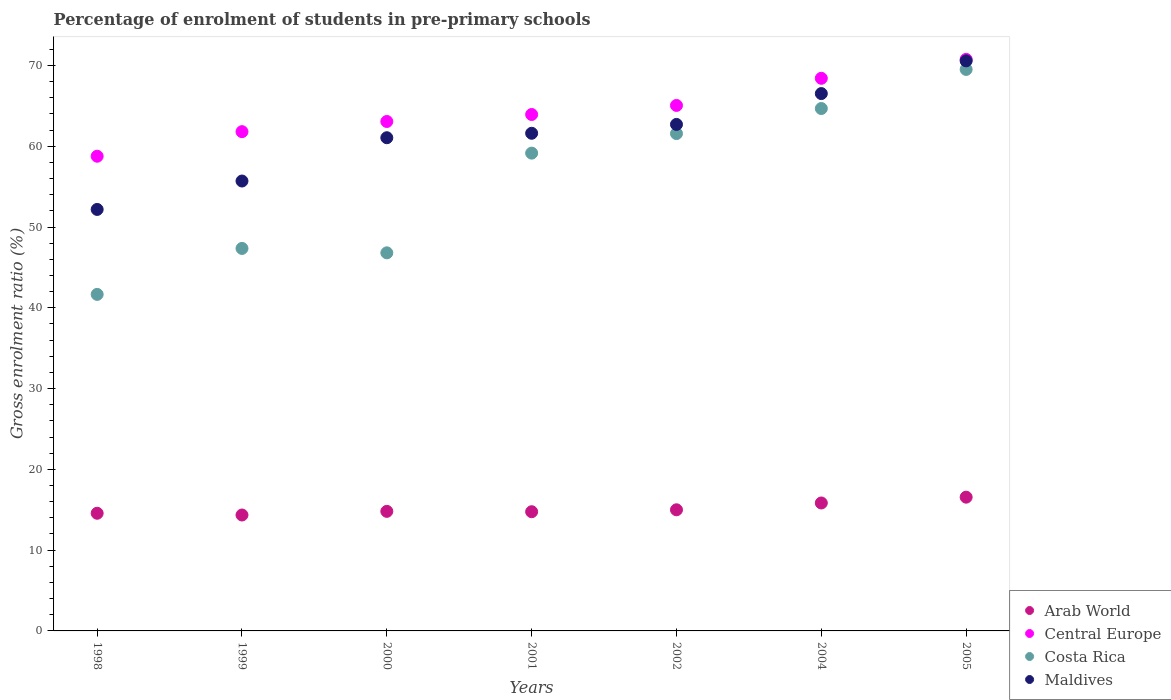Is the number of dotlines equal to the number of legend labels?
Your answer should be compact. Yes. What is the percentage of students enrolled in pre-primary schools in Costa Rica in 1999?
Give a very brief answer. 47.35. Across all years, what is the maximum percentage of students enrolled in pre-primary schools in Arab World?
Offer a terse response. 16.56. Across all years, what is the minimum percentage of students enrolled in pre-primary schools in Maldives?
Offer a very short reply. 52.17. In which year was the percentage of students enrolled in pre-primary schools in Costa Rica maximum?
Ensure brevity in your answer.  2005. In which year was the percentage of students enrolled in pre-primary schools in Maldives minimum?
Your answer should be compact. 1998. What is the total percentage of students enrolled in pre-primary schools in Costa Rica in the graph?
Give a very brief answer. 390.69. What is the difference between the percentage of students enrolled in pre-primary schools in Maldives in 2000 and that in 2001?
Provide a short and direct response. -0.55. What is the difference between the percentage of students enrolled in pre-primary schools in Maldives in 2002 and the percentage of students enrolled in pre-primary schools in Arab World in 2001?
Your answer should be compact. 47.94. What is the average percentage of students enrolled in pre-primary schools in Central Europe per year?
Ensure brevity in your answer.  64.54. In the year 2004, what is the difference between the percentage of students enrolled in pre-primary schools in Costa Rica and percentage of students enrolled in pre-primary schools in Maldives?
Keep it short and to the point. -1.85. What is the ratio of the percentage of students enrolled in pre-primary schools in Central Europe in 2004 to that in 2005?
Offer a terse response. 0.97. Is the percentage of students enrolled in pre-primary schools in Central Europe in 1998 less than that in 2000?
Give a very brief answer. Yes. Is the difference between the percentage of students enrolled in pre-primary schools in Costa Rica in 1998 and 2002 greater than the difference between the percentage of students enrolled in pre-primary schools in Maldives in 1998 and 2002?
Provide a short and direct response. No. What is the difference between the highest and the second highest percentage of students enrolled in pre-primary schools in Maldives?
Offer a terse response. 4.05. What is the difference between the highest and the lowest percentage of students enrolled in pre-primary schools in Costa Rica?
Give a very brief answer. 27.85. Does the percentage of students enrolled in pre-primary schools in Arab World monotonically increase over the years?
Your answer should be compact. No. Is the percentage of students enrolled in pre-primary schools in Maldives strictly greater than the percentage of students enrolled in pre-primary schools in Costa Rica over the years?
Keep it short and to the point. Yes. Is the percentage of students enrolled in pre-primary schools in Arab World strictly less than the percentage of students enrolled in pre-primary schools in Central Europe over the years?
Your answer should be very brief. Yes. How many years are there in the graph?
Your answer should be very brief. 7. What is the difference between two consecutive major ticks on the Y-axis?
Give a very brief answer. 10. Are the values on the major ticks of Y-axis written in scientific E-notation?
Offer a very short reply. No. Does the graph contain any zero values?
Your response must be concise. No. What is the title of the graph?
Your answer should be compact. Percentage of enrolment of students in pre-primary schools. What is the label or title of the X-axis?
Give a very brief answer. Years. What is the Gross enrolment ratio (%) in Arab World in 1998?
Provide a succinct answer. 14.56. What is the Gross enrolment ratio (%) of Central Europe in 1998?
Offer a terse response. 58.76. What is the Gross enrolment ratio (%) of Costa Rica in 1998?
Give a very brief answer. 41.66. What is the Gross enrolment ratio (%) in Maldives in 1998?
Offer a terse response. 52.17. What is the Gross enrolment ratio (%) of Arab World in 1999?
Your response must be concise. 14.35. What is the Gross enrolment ratio (%) in Central Europe in 1999?
Your answer should be compact. 61.8. What is the Gross enrolment ratio (%) in Costa Rica in 1999?
Provide a succinct answer. 47.35. What is the Gross enrolment ratio (%) of Maldives in 1999?
Offer a very short reply. 55.69. What is the Gross enrolment ratio (%) of Arab World in 2000?
Offer a very short reply. 14.8. What is the Gross enrolment ratio (%) of Central Europe in 2000?
Make the answer very short. 63.06. What is the Gross enrolment ratio (%) of Costa Rica in 2000?
Your answer should be compact. 46.8. What is the Gross enrolment ratio (%) in Maldives in 2000?
Keep it short and to the point. 61.05. What is the Gross enrolment ratio (%) of Arab World in 2001?
Your answer should be very brief. 14.76. What is the Gross enrolment ratio (%) in Central Europe in 2001?
Provide a short and direct response. 63.93. What is the Gross enrolment ratio (%) of Costa Rica in 2001?
Provide a short and direct response. 59.14. What is the Gross enrolment ratio (%) in Maldives in 2001?
Provide a short and direct response. 61.6. What is the Gross enrolment ratio (%) in Arab World in 2002?
Offer a terse response. 14.99. What is the Gross enrolment ratio (%) in Central Europe in 2002?
Make the answer very short. 65.05. What is the Gross enrolment ratio (%) of Costa Rica in 2002?
Give a very brief answer. 61.56. What is the Gross enrolment ratio (%) in Maldives in 2002?
Provide a succinct answer. 62.7. What is the Gross enrolment ratio (%) in Arab World in 2004?
Your answer should be compact. 15.84. What is the Gross enrolment ratio (%) of Central Europe in 2004?
Make the answer very short. 68.41. What is the Gross enrolment ratio (%) of Costa Rica in 2004?
Make the answer very short. 64.67. What is the Gross enrolment ratio (%) of Maldives in 2004?
Keep it short and to the point. 66.52. What is the Gross enrolment ratio (%) in Arab World in 2005?
Your answer should be very brief. 16.56. What is the Gross enrolment ratio (%) of Central Europe in 2005?
Your answer should be compact. 70.75. What is the Gross enrolment ratio (%) of Costa Rica in 2005?
Ensure brevity in your answer.  69.51. What is the Gross enrolment ratio (%) in Maldives in 2005?
Offer a very short reply. 70.57. Across all years, what is the maximum Gross enrolment ratio (%) of Arab World?
Provide a short and direct response. 16.56. Across all years, what is the maximum Gross enrolment ratio (%) of Central Europe?
Provide a short and direct response. 70.75. Across all years, what is the maximum Gross enrolment ratio (%) in Costa Rica?
Ensure brevity in your answer.  69.51. Across all years, what is the maximum Gross enrolment ratio (%) of Maldives?
Your answer should be very brief. 70.57. Across all years, what is the minimum Gross enrolment ratio (%) in Arab World?
Provide a succinct answer. 14.35. Across all years, what is the minimum Gross enrolment ratio (%) in Central Europe?
Keep it short and to the point. 58.76. Across all years, what is the minimum Gross enrolment ratio (%) of Costa Rica?
Provide a short and direct response. 41.66. Across all years, what is the minimum Gross enrolment ratio (%) in Maldives?
Provide a short and direct response. 52.17. What is the total Gross enrolment ratio (%) of Arab World in the graph?
Give a very brief answer. 105.86. What is the total Gross enrolment ratio (%) of Central Europe in the graph?
Your answer should be compact. 451.76. What is the total Gross enrolment ratio (%) in Costa Rica in the graph?
Provide a short and direct response. 390.69. What is the total Gross enrolment ratio (%) in Maldives in the graph?
Provide a short and direct response. 430.3. What is the difference between the Gross enrolment ratio (%) of Arab World in 1998 and that in 1999?
Your response must be concise. 0.22. What is the difference between the Gross enrolment ratio (%) of Central Europe in 1998 and that in 1999?
Provide a short and direct response. -3.04. What is the difference between the Gross enrolment ratio (%) of Costa Rica in 1998 and that in 1999?
Offer a very short reply. -5.69. What is the difference between the Gross enrolment ratio (%) of Maldives in 1998 and that in 1999?
Ensure brevity in your answer.  -3.52. What is the difference between the Gross enrolment ratio (%) in Arab World in 1998 and that in 2000?
Your answer should be compact. -0.24. What is the difference between the Gross enrolment ratio (%) in Central Europe in 1998 and that in 2000?
Give a very brief answer. -4.3. What is the difference between the Gross enrolment ratio (%) in Costa Rica in 1998 and that in 2000?
Keep it short and to the point. -5.14. What is the difference between the Gross enrolment ratio (%) in Maldives in 1998 and that in 2000?
Provide a succinct answer. -8.88. What is the difference between the Gross enrolment ratio (%) in Arab World in 1998 and that in 2001?
Offer a terse response. -0.19. What is the difference between the Gross enrolment ratio (%) in Central Europe in 1998 and that in 2001?
Your response must be concise. -5.17. What is the difference between the Gross enrolment ratio (%) in Costa Rica in 1998 and that in 2001?
Provide a succinct answer. -17.49. What is the difference between the Gross enrolment ratio (%) of Maldives in 1998 and that in 2001?
Offer a very short reply. -9.43. What is the difference between the Gross enrolment ratio (%) of Arab World in 1998 and that in 2002?
Your response must be concise. -0.43. What is the difference between the Gross enrolment ratio (%) of Central Europe in 1998 and that in 2002?
Provide a succinct answer. -6.29. What is the difference between the Gross enrolment ratio (%) in Costa Rica in 1998 and that in 2002?
Keep it short and to the point. -19.91. What is the difference between the Gross enrolment ratio (%) in Maldives in 1998 and that in 2002?
Ensure brevity in your answer.  -10.53. What is the difference between the Gross enrolment ratio (%) in Arab World in 1998 and that in 2004?
Provide a short and direct response. -1.27. What is the difference between the Gross enrolment ratio (%) in Central Europe in 1998 and that in 2004?
Make the answer very short. -9.65. What is the difference between the Gross enrolment ratio (%) of Costa Rica in 1998 and that in 2004?
Provide a succinct answer. -23.01. What is the difference between the Gross enrolment ratio (%) in Maldives in 1998 and that in 2004?
Your answer should be compact. -14.34. What is the difference between the Gross enrolment ratio (%) in Arab World in 1998 and that in 2005?
Keep it short and to the point. -1.99. What is the difference between the Gross enrolment ratio (%) in Central Europe in 1998 and that in 2005?
Your response must be concise. -11.99. What is the difference between the Gross enrolment ratio (%) of Costa Rica in 1998 and that in 2005?
Give a very brief answer. -27.85. What is the difference between the Gross enrolment ratio (%) of Maldives in 1998 and that in 2005?
Offer a very short reply. -18.39. What is the difference between the Gross enrolment ratio (%) of Arab World in 1999 and that in 2000?
Provide a succinct answer. -0.45. What is the difference between the Gross enrolment ratio (%) of Central Europe in 1999 and that in 2000?
Your answer should be compact. -1.26. What is the difference between the Gross enrolment ratio (%) in Costa Rica in 1999 and that in 2000?
Provide a short and direct response. 0.55. What is the difference between the Gross enrolment ratio (%) of Maldives in 1999 and that in 2000?
Make the answer very short. -5.36. What is the difference between the Gross enrolment ratio (%) in Arab World in 1999 and that in 2001?
Make the answer very short. -0.41. What is the difference between the Gross enrolment ratio (%) of Central Europe in 1999 and that in 2001?
Give a very brief answer. -2.12. What is the difference between the Gross enrolment ratio (%) of Costa Rica in 1999 and that in 2001?
Your answer should be compact. -11.8. What is the difference between the Gross enrolment ratio (%) in Maldives in 1999 and that in 2001?
Your answer should be very brief. -5.91. What is the difference between the Gross enrolment ratio (%) in Arab World in 1999 and that in 2002?
Your answer should be compact. -0.65. What is the difference between the Gross enrolment ratio (%) in Central Europe in 1999 and that in 2002?
Offer a very short reply. -3.24. What is the difference between the Gross enrolment ratio (%) of Costa Rica in 1999 and that in 2002?
Ensure brevity in your answer.  -14.22. What is the difference between the Gross enrolment ratio (%) in Maldives in 1999 and that in 2002?
Ensure brevity in your answer.  -7.01. What is the difference between the Gross enrolment ratio (%) in Arab World in 1999 and that in 2004?
Keep it short and to the point. -1.49. What is the difference between the Gross enrolment ratio (%) in Central Europe in 1999 and that in 2004?
Provide a succinct answer. -6.6. What is the difference between the Gross enrolment ratio (%) in Costa Rica in 1999 and that in 2004?
Provide a succinct answer. -17.32. What is the difference between the Gross enrolment ratio (%) of Maldives in 1999 and that in 2004?
Your answer should be compact. -10.82. What is the difference between the Gross enrolment ratio (%) of Arab World in 1999 and that in 2005?
Your answer should be compact. -2.21. What is the difference between the Gross enrolment ratio (%) in Central Europe in 1999 and that in 2005?
Keep it short and to the point. -8.95. What is the difference between the Gross enrolment ratio (%) of Costa Rica in 1999 and that in 2005?
Provide a short and direct response. -22.16. What is the difference between the Gross enrolment ratio (%) in Maldives in 1999 and that in 2005?
Give a very brief answer. -14.88. What is the difference between the Gross enrolment ratio (%) in Arab World in 2000 and that in 2001?
Provide a short and direct response. 0.05. What is the difference between the Gross enrolment ratio (%) in Central Europe in 2000 and that in 2001?
Your answer should be very brief. -0.86. What is the difference between the Gross enrolment ratio (%) of Costa Rica in 2000 and that in 2001?
Provide a short and direct response. -12.34. What is the difference between the Gross enrolment ratio (%) in Maldives in 2000 and that in 2001?
Ensure brevity in your answer.  -0.55. What is the difference between the Gross enrolment ratio (%) of Arab World in 2000 and that in 2002?
Offer a terse response. -0.19. What is the difference between the Gross enrolment ratio (%) in Central Europe in 2000 and that in 2002?
Keep it short and to the point. -1.99. What is the difference between the Gross enrolment ratio (%) in Costa Rica in 2000 and that in 2002?
Your answer should be compact. -14.76. What is the difference between the Gross enrolment ratio (%) of Maldives in 2000 and that in 2002?
Give a very brief answer. -1.65. What is the difference between the Gross enrolment ratio (%) in Arab World in 2000 and that in 2004?
Provide a succinct answer. -1.04. What is the difference between the Gross enrolment ratio (%) of Central Europe in 2000 and that in 2004?
Offer a very short reply. -5.35. What is the difference between the Gross enrolment ratio (%) in Costa Rica in 2000 and that in 2004?
Keep it short and to the point. -17.86. What is the difference between the Gross enrolment ratio (%) of Maldives in 2000 and that in 2004?
Offer a terse response. -5.46. What is the difference between the Gross enrolment ratio (%) of Arab World in 2000 and that in 2005?
Your response must be concise. -1.76. What is the difference between the Gross enrolment ratio (%) of Central Europe in 2000 and that in 2005?
Provide a short and direct response. -7.69. What is the difference between the Gross enrolment ratio (%) in Costa Rica in 2000 and that in 2005?
Your answer should be very brief. -22.7. What is the difference between the Gross enrolment ratio (%) in Maldives in 2000 and that in 2005?
Give a very brief answer. -9.52. What is the difference between the Gross enrolment ratio (%) in Arab World in 2001 and that in 2002?
Your answer should be compact. -0.24. What is the difference between the Gross enrolment ratio (%) of Central Europe in 2001 and that in 2002?
Provide a short and direct response. -1.12. What is the difference between the Gross enrolment ratio (%) in Costa Rica in 2001 and that in 2002?
Ensure brevity in your answer.  -2.42. What is the difference between the Gross enrolment ratio (%) in Maldives in 2001 and that in 2002?
Offer a very short reply. -1.1. What is the difference between the Gross enrolment ratio (%) of Arab World in 2001 and that in 2004?
Your response must be concise. -1.08. What is the difference between the Gross enrolment ratio (%) of Central Europe in 2001 and that in 2004?
Make the answer very short. -4.48. What is the difference between the Gross enrolment ratio (%) of Costa Rica in 2001 and that in 2004?
Your answer should be compact. -5.52. What is the difference between the Gross enrolment ratio (%) in Maldives in 2001 and that in 2004?
Give a very brief answer. -4.91. What is the difference between the Gross enrolment ratio (%) in Arab World in 2001 and that in 2005?
Your response must be concise. -1.8. What is the difference between the Gross enrolment ratio (%) of Central Europe in 2001 and that in 2005?
Provide a succinct answer. -6.83. What is the difference between the Gross enrolment ratio (%) in Costa Rica in 2001 and that in 2005?
Offer a terse response. -10.36. What is the difference between the Gross enrolment ratio (%) of Maldives in 2001 and that in 2005?
Provide a succinct answer. -8.96. What is the difference between the Gross enrolment ratio (%) in Arab World in 2002 and that in 2004?
Offer a terse response. -0.84. What is the difference between the Gross enrolment ratio (%) in Central Europe in 2002 and that in 2004?
Offer a very short reply. -3.36. What is the difference between the Gross enrolment ratio (%) in Costa Rica in 2002 and that in 2004?
Make the answer very short. -3.1. What is the difference between the Gross enrolment ratio (%) of Maldives in 2002 and that in 2004?
Make the answer very short. -3.82. What is the difference between the Gross enrolment ratio (%) in Arab World in 2002 and that in 2005?
Your answer should be very brief. -1.56. What is the difference between the Gross enrolment ratio (%) in Central Europe in 2002 and that in 2005?
Provide a succinct answer. -5.7. What is the difference between the Gross enrolment ratio (%) of Costa Rica in 2002 and that in 2005?
Provide a succinct answer. -7.94. What is the difference between the Gross enrolment ratio (%) of Maldives in 2002 and that in 2005?
Make the answer very short. -7.87. What is the difference between the Gross enrolment ratio (%) in Arab World in 2004 and that in 2005?
Your answer should be very brief. -0.72. What is the difference between the Gross enrolment ratio (%) in Central Europe in 2004 and that in 2005?
Make the answer very short. -2.35. What is the difference between the Gross enrolment ratio (%) in Costa Rica in 2004 and that in 2005?
Your response must be concise. -4.84. What is the difference between the Gross enrolment ratio (%) of Maldives in 2004 and that in 2005?
Your answer should be very brief. -4.05. What is the difference between the Gross enrolment ratio (%) in Arab World in 1998 and the Gross enrolment ratio (%) in Central Europe in 1999?
Offer a very short reply. -47.24. What is the difference between the Gross enrolment ratio (%) of Arab World in 1998 and the Gross enrolment ratio (%) of Costa Rica in 1999?
Provide a succinct answer. -32.78. What is the difference between the Gross enrolment ratio (%) in Arab World in 1998 and the Gross enrolment ratio (%) in Maldives in 1999?
Your answer should be very brief. -41.13. What is the difference between the Gross enrolment ratio (%) of Central Europe in 1998 and the Gross enrolment ratio (%) of Costa Rica in 1999?
Keep it short and to the point. 11.41. What is the difference between the Gross enrolment ratio (%) in Central Europe in 1998 and the Gross enrolment ratio (%) in Maldives in 1999?
Provide a short and direct response. 3.07. What is the difference between the Gross enrolment ratio (%) of Costa Rica in 1998 and the Gross enrolment ratio (%) of Maldives in 1999?
Your answer should be compact. -14.03. What is the difference between the Gross enrolment ratio (%) of Arab World in 1998 and the Gross enrolment ratio (%) of Central Europe in 2000?
Give a very brief answer. -48.5. What is the difference between the Gross enrolment ratio (%) in Arab World in 1998 and the Gross enrolment ratio (%) in Costa Rica in 2000?
Provide a succinct answer. -32.24. What is the difference between the Gross enrolment ratio (%) in Arab World in 1998 and the Gross enrolment ratio (%) in Maldives in 2000?
Your response must be concise. -46.49. What is the difference between the Gross enrolment ratio (%) in Central Europe in 1998 and the Gross enrolment ratio (%) in Costa Rica in 2000?
Your answer should be very brief. 11.96. What is the difference between the Gross enrolment ratio (%) of Central Europe in 1998 and the Gross enrolment ratio (%) of Maldives in 2000?
Provide a short and direct response. -2.29. What is the difference between the Gross enrolment ratio (%) of Costa Rica in 1998 and the Gross enrolment ratio (%) of Maldives in 2000?
Provide a short and direct response. -19.39. What is the difference between the Gross enrolment ratio (%) of Arab World in 1998 and the Gross enrolment ratio (%) of Central Europe in 2001?
Your answer should be very brief. -49.36. What is the difference between the Gross enrolment ratio (%) of Arab World in 1998 and the Gross enrolment ratio (%) of Costa Rica in 2001?
Give a very brief answer. -44.58. What is the difference between the Gross enrolment ratio (%) in Arab World in 1998 and the Gross enrolment ratio (%) in Maldives in 2001?
Provide a succinct answer. -47.04. What is the difference between the Gross enrolment ratio (%) of Central Europe in 1998 and the Gross enrolment ratio (%) of Costa Rica in 2001?
Your answer should be very brief. -0.38. What is the difference between the Gross enrolment ratio (%) of Central Europe in 1998 and the Gross enrolment ratio (%) of Maldives in 2001?
Offer a very short reply. -2.84. What is the difference between the Gross enrolment ratio (%) in Costa Rica in 1998 and the Gross enrolment ratio (%) in Maldives in 2001?
Your response must be concise. -19.94. What is the difference between the Gross enrolment ratio (%) of Arab World in 1998 and the Gross enrolment ratio (%) of Central Europe in 2002?
Offer a very short reply. -50.48. What is the difference between the Gross enrolment ratio (%) of Arab World in 1998 and the Gross enrolment ratio (%) of Costa Rica in 2002?
Your response must be concise. -47. What is the difference between the Gross enrolment ratio (%) in Arab World in 1998 and the Gross enrolment ratio (%) in Maldives in 2002?
Your answer should be very brief. -48.13. What is the difference between the Gross enrolment ratio (%) of Central Europe in 1998 and the Gross enrolment ratio (%) of Costa Rica in 2002?
Your answer should be very brief. -2.8. What is the difference between the Gross enrolment ratio (%) in Central Europe in 1998 and the Gross enrolment ratio (%) in Maldives in 2002?
Your response must be concise. -3.94. What is the difference between the Gross enrolment ratio (%) of Costa Rica in 1998 and the Gross enrolment ratio (%) of Maldives in 2002?
Keep it short and to the point. -21.04. What is the difference between the Gross enrolment ratio (%) of Arab World in 1998 and the Gross enrolment ratio (%) of Central Europe in 2004?
Your answer should be very brief. -53.84. What is the difference between the Gross enrolment ratio (%) of Arab World in 1998 and the Gross enrolment ratio (%) of Costa Rica in 2004?
Ensure brevity in your answer.  -50.1. What is the difference between the Gross enrolment ratio (%) in Arab World in 1998 and the Gross enrolment ratio (%) in Maldives in 2004?
Provide a short and direct response. -51.95. What is the difference between the Gross enrolment ratio (%) in Central Europe in 1998 and the Gross enrolment ratio (%) in Costa Rica in 2004?
Give a very brief answer. -5.91. What is the difference between the Gross enrolment ratio (%) in Central Europe in 1998 and the Gross enrolment ratio (%) in Maldives in 2004?
Your response must be concise. -7.76. What is the difference between the Gross enrolment ratio (%) of Costa Rica in 1998 and the Gross enrolment ratio (%) of Maldives in 2004?
Offer a terse response. -24.86. What is the difference between the Gross enrolment ratio (%) in Arab World in 1998 and the Gross enrolment ratio (%) in Central Europe in 2005?
Ensure brevity in your answer.  -56.19. What is the difference between the Gross enrolment ratio (%) in Arab World in 1998 and the Gross enrolment ratio (%) in Costa Rica in 2005?
Provide a succinct answer. -54.94. What is the difference between the Gross enrolment ratio (%) in Arab World in 1998 and the Gross enrolment ratio (%) in Maldives in 2005?
Make the answer very short. -56. What is the difference between the Gross enrolment ratio (%) of Central Europe in 1998 and the Gross enrolment ratio (%) of Costa Rica in 2005?
Provide a succinct answer. -10.75. What is the difference between the Gross enrolment ratio (%) of Central Europe in 1998 and the Gross enrolment ratio (%) of Maldives in 2005?
Your answer should be very brief. -11.81. What is the difference between the Gross enrolment ratio (%) in Costa Rica in 1998 and the Gross enrolment ratio (%) in Maldives in 2005?
Your answer should be compact. -28.91. What is the difference between the Gross enrolment ratio (%) of Arab World in 1999 and the Gross enrolment ratio (%) of Central Europe in 2000?
Provide a succinct answer. -48.71. What is the difference between the Gross enrolment ratio (%) in Arab World in 1999 and the Gross enrolment ratio (%) in Costa Rica in 2000?
Provide a succinct answer. -32.45. What is the difference between the Gross enrolment ratio (%) of Arab World in 1999 and the Gross enrolment ratio (%) of Maldives in 2000?
Offer a terse response. -46.7. What is the difference between the Gross enrolment ratio (%) of Central Europe in 1999 and the Gross enrolment ratio (%) of Costa Rica in 2000?
Offer a terse response. 15. What is the difference between the Gross enrolment ratio (%) in Central Europe in 1999 and the Gross enrolment ratio (%) in Maldives in 2000?
Offer a very short reply. 0.75. What is the difference between the Gross enrolment ratio (%) of Costa Rica in 1999 and the Gross enrolment ratio (%) of Maldives in 2000?
Ensure brevity in your answer.  -13.7. What is the difference between the Gross enrolment ratio (%) of Arab World in 1999 and the Gross enrolment ratio (%) of Central Europe in 2001?
Your response must be concise. -49.58. What is the difference between the Gross enrolment ratio (%) of Arab World in 1999 and the Gross enrolment ratio (%) of Costa Rica in 2001?
Give a very brief answer. -44.8. What is the difference between the Gross enrolment ratio (%) in Arab World in 1999 and the Gross enrolment ratio (%) in Maldives in 2001?
Your response must be concise. -47.25. What is the difference between the Gross enrolment ratio (%) of Central Europe in 1999 and the Gross enrolment ratio (%) of Costa Rica in 2001?
Provide a succinct answer. 2.66. What is the difference between the Gross enrolment ratio (%) of Central Europe in 1999 and the Gross enrolment ratio (%) of Maldives in 2001?
Your answer should be very brief. 0.2. What is the difference between the Gross enrolment ratio (%) in Costa Rica in 1999 and the Gross enrolment ratio (%) in Maldives in 2001?
Offer a terse response. -14.25. What is the difference between the Gross enrolment ratio (%) in Arab World in 1999 and the Gross enrolment ratio (%) in Central Europe in 2002?
Your response must be concise. -50.7. What is the difference between the Gross enrolment ratio (%) of Arab World in 1999 and the Gross enrolment ratio (%) of Costa Rica in 2002?
Provide a succinct answer. -47.21. What is the difference between the Gross enrolment ratio (%) of Arab World in 1999 and the Gross enrolment ratio (%) of Maldives in 2002?
Your response must be concise. -48.35. What is the difference between the Gross enrolment ratio (%) in Central Europe in 1999 and the Gross enrolment ratio (%) in Costa Rica in 2002?
Offer a terse response. 0.24. What is the difference between the Gross enrolment ratio (%) in Central Europe in 1999 and the Gross enrolment ratio (%) in Maldives in 2002?
Make the answer very short. -0.9. What is the difference between the Gross enrolment ratio (%) in Costa Rica in 1999 and the Gross enrolment ratio (%) in Maldives in 2002?
Your answer should be compact. -15.35. What is the difference between the Gross enrolment ratio (%) in Arab World in 1999 and the Gross enrolment ratio (%) in Central Europe in 2004?
Your answer should be very brief. -54.06. What is the difference between the Gross enrolment ratio (%) of Arab World in 1999 and the Gross enrolment ratio (%) of Costa Rica in 2004?
Keep it short and to the point. -50.32. What is the difference between the Gross enrolment ratio (%) in Arab World in 1999 and the Gross enrolment ratio (%) in Maldives in 2004?
Make the answer very short. -52.17. What is the difference between the Gross enrolment ratio (%) of Central Europe in 1999 and the Gross enrolment ratio (%) of Costa Rica in 2004?
Your response must be concise. -2.86. What is the difference between the Gross enrolment ratio (%) of Central Europe in 1999 and the Gross enrolment ratio (%) of Maldives in 2004?
Your response must be concise. -4.71. What is the difference between the Gross enrolment ratio (%) of Costa Rica in 1999 and the Gross enrolment ratio (%) of Maldives in 2004?
Ensure brevity in your answer.  -19.17. What is the difference between the Gross enrolment ratio (%) in Arab World in 1999 and the Gross enrolment ratio (%) in Central Europe in 2005?
Give a very brief answer. -56.4. What is the difference between the Gross enrolment ratio (%) of Arab World in 1999 and the Gross enrolment ratio (%) of Costa Rica in 2005?
Your response must be concise. -55.16. What is the difference between the Gross enrolment ratio (%) of Arab World in 1999 and the Gross enrolment ratio (%) of Maldives in 2005?
Offer a terse response. -56.22. What is the difference between the Gross enrolment ratio (%) in Central Europe in 1999 and the Gross enrolment ratio (%) in Costa Rica in 2005?
Give a very brief answer. -7.7. What is the difference between the Gross enrolment ratio (%) in Central Europe in 1999 and the Gross enrolment ratio (%) in Maldives in 2005?
Ensure brevity in your answer.  -8.76. What is the difference between the Gross enrolment ratio (%) in Costa Rica in 1999 and the Gross enrolment ratio (%) in Maldives in 2005?
Offer a terse response. -23.22. What is the difference between the Gross enrolment ratio (%) of Arab World in 2000 and the Gross enrolment ratio (%) of Central Europe in 2001?
Keep it short and to the point. -49.13. What is the difference between the Gross enrolment ratio (%) in Arab World in 2000 and the Gross enrolment ratio (%) in Costa Rica in 2001?
Your response must be concise. -44.34. What is the difference between the Gross enrolment ratio (%) in Arab World in 2000 and the Gross enrolment ratio (%) in Maldives in 2001?
Provide a succinct answer. -46.8. What is the difference between the Gross enrolment ratio (%) in Central Europe in 2000 and the Gross enrolment ratio (%) in Costa Rica in 2001?
Your response must be concise. 3.92. What is the difference between the Gross enrolment ratio (%) in Central Europe in 2000 and the Gross enrolment ratio (%) in Maldives in 2001?
Your response must be concise. 1.46. What is the difference between the Gross enrolment ratio (%) in Costa Rica in 2000 and the Gross enrolment ratio (%) in Maldives in 2001?
Your answer should be very brief. -14.8. What is the difference between the Gross enrolment ratio (%) in Arab World in 2000 and the Gross enrolment ratio (%) in Central Europe in 2002?
Keep it short and to the point. -50.25. What is the difference between the Gross enrolment ratio (%) of Arab World in 2000 and the Gross enrolment ratio (%) of Costa Rica in 2002?
Offer a very short reply. -46.76. What is the difference between the Gross enrolment ratio (%) of Arab World in 2000 and the Gross enrolment ratio (%) of Maldives in 2002?
Keep it short and to the point. -47.9. What is the difference between the Gross enrolment ratio (%) of Central Europe in 2000 and the Gross enrolment ratio (%) of Costa Rica in 2002?
Provide a short and direct response. 1.5. What is the difference between the Gross enrolment ratio (%) of Central Europe in 2000 and the Gross enrolment ratio (%) of Maldives in 2002?
Your answer should be compact. 0.36. What is the difference between the Gross enrolment ratio (%) of Costa Rica in 2000 and the Gross enrolment ratio (%) of Maldives in 2002?
Keep it short and to the point. -15.9. What is the difference between the Gross enrolment ratio (%) of Arab World in 2000 and the Gross enrolment ratio (%) of Central Europe in 2004?
Ensure brevity in your answer.  -53.61. What is the difference between the Gross enrolment ratio (%) of Arab World in 2000 and the Gross enrolment ratio (%) of Costa Rica in 2004?
Your answer should be compact. -49.87. What is the difference between the Gross enrolment ratio (%) in Arab World in 2000 and the Gross enrolment ratio (%) in Maldives in 2004?
Keep it short and to the point. -51.72. What is the difference between the Gross enrolment ratio (%) in Central Europe in 2000 and the Gross enrolment ratio (%) in Costa Rica in 2004?
Give a very brief answer. -1.6. What is the difference between the Gross enrolment ratio (%) of Central Europe in 2000 and the Gross enrolment ratio (%) of Maldives in 2004?
Offer a terse response. -3.45. What is the difference between the Gross enrolment ratio (%) of Costa Rica in 2000 and the Gross enrolment ratio (%) of Maldives in 2004?
Make the answer very short. -19.71. What is the difference between the Gross enrolment ratio (%) in Arab World in 2000 and the Gross enrolment ratio (%) in Central Europe in 2005?
Offer a very short reply. -55.95. What is the difference between the Gross enrolment ratio (%) of Arab World in 2000 and the Gross enrolment ratio (%) of Costa Rica in 2005?
Your answer should be very brief. -54.71. What is the difference between the Gross enrolment ratio (%) in Arab World in 2000 and the Gross enrolment ratio (%) in Maldives in 2005?
Offer a very short reply. -55.77. What is the difference between the Gross enrolment ratio (%) in Central Europe in 2000 and the Gross enrolment ratio (%) in Costa Rica in 2005?
Offer a terse response. -6.44. What is the difference between the Gross enrolment ratio (%) in Central Europe in 2000 and the Gross enrolment ratio (%) in Maldives in 2005?
Ensure brevity in your answer.  -7.51. What is the difference between the Gross enrolment ratio (%) of Costa Rica in 2000 and the Gross enrolment ratio (%) of Maldives in 2005?
Make the answer very short. -23.76. What is the difference between the Gross enrolment ratio (%) of Arab World in 2001 and the Gross enrolment ratio (%) of Central Europe in 2002?
Your answer should be compact. -50.29. What is the difference between the Gross enrolment ratio (%) in Arab World in 2001 and the Gross enrolment ratio (%) in Costa Rica in 2002?
Your response must be concise. -46.81. What is the difference between the Gross enrolment ratio (%) in Arab World in 2001 and the Gross enrolment ratio (%) in Maldives in 2002?
Your response must be concise. -47.94. What is the difference between the Gross enrolment ratio (%) of Central Europe in 2001 and the Gross enrolment ratio (%) of Costa Rica in 2002?
Give a very brief answer. 2.36. What is the difference between the Gross enrolment ratio (%) of Central Europe in 2001 and the Gross enrolment ratio (%) of Maldives in 2002?
Offer a terse response. 1.23. What is the difference between the Gross enrolment ratio (%) in Costa Rica in 2001 and the Gross enrolment ratio (%) in Maldives in 2002?
Keep it short and to the point. -3.56. What is the difference between the Gross enrolment ratio (%) of Arab World in 2001 and the Gross enrolment ratio (%) of Central Europe in 2004?
Offer a very short reply. -53.65. What is the difference between the Gross enrolment ratio (%) of Arab World in 2001 and the Gross enrolment ratio (%) of Costa Rica in 2004?
Provide a short and direct response. -49.91. What is the difference between the Gross enrolment ratio (%) in Arab World in 2001 and the Gross enrolment ratio (%) in Maldives in 2004?
Provide a succinct answer. -51.76. What is the difference between the Gross enrolment ratio (%) of Central Europe in 2001 and the Gross enrolment ratio (%) of Costa Rica in 2004?
Your answer should be very brief. -0.74. What is the difference between the Gross enrolment ratio (%) in Central Europe in 2001 and the Gross enrolment ratio (%) in Maldives in 2004?
Make the answer very short. -2.59. What is the difference between the Gross enrolment ratio (%) of Costa Rica in 2001 and the Gross enrolment ratio (%) of Maldives in 2004?
Offer a very short reply. -7.37. What is the difference between the Gross enrolment ratio (%) of Arab World in 2001 and the Gross enrolment ratio (%) of Central Europe in 2005?
Give a very brief answer. -56. What is the difference between the Gross enrolment ratio (%) of Arab World in 2001 and the Gross enrolment ratio (%) of Costa Rica in 2005?
Your answer should be compact. -54.75. What is the difference between the Gross enrolment ratio (%) of Arab World in 2001 and the Gross enrolment ratio (%) of Maldives in 2005?
Make the answer very short. -55.81. What is the difference between the Gross enrolment ratio (%) of Central Europe in 2001 and the Gross enrolment ratio (%) of Costa Rica in 2005?
Give a very brief answer. -5.58. What is the difference between the Gross enrolment ratio (%) of Central Europe in 2001 and the Gross enrolment ratio (%) of Maldives in 2005?
Provide a short and direct response. -6.64. What is the difference between the Gross enrolment ratio (%) of Costa Rica in 2001 and the Gross enrolment ratio (%) of Maldives in 2005?
Offer a very short reply. -11.42. What is the difference between the Gross enrolment ratio (%) in Arab World in 2002 and the Gross enrolment ratio (%) in Central Europe in 2004?
Your response must be concise. -53.41. What is the difference between the Gross enrolment ratio (%) of Arab World in 2002 and the Gross enrolment ratio (%) of Costa Rica in 2004?
Ensure brevity in your answer.  -49.67. What is the difference between the Gross enrolment ratio (%) of Arab World in 2002 and the Gross enrolment ratio (%) of Maldives in 2004?
Give a very brief answer. -51.52. What is the difference between the Gross enrolment ratio (%) in Central Europe in 2002 and the Gross enrolment ratio (%) in Costa Rica in 2004?
Ensure brevity in your answer.  0.38. What is the difference between the Gross enrolment ratio (%) in Central Europe in 2002 and the Gross enrolment ratio (%) in Maldives in 2004?
Your answer should be very brief. -1.47. What is the difference between the Gross enrolment ratio (%) in Costa Rica in 2002 and the Gross enrolment ratio (%) in Maldives in 2004?
Ensure brevity in your answer.  -4.95. What is the difference between the Gross enrolment ratio (%) of Arab World in 2002 and the Gross enrolment ratio (%) of Central Europe in 2005?
Provide a succinct answer. -55.76. What is the difference between the Gross enrolment ratio (%) of Arab World in 2002 and the Gross enrolment ratio (%) of Costa Rica in 2005?
Give a very brief answer. -54.51. What is the difference between the Gross enrolment ratio (%) of Arab World in 2002 and the Gross enrolment ratio (%) of Maldives in 2005?
Your answer should be compact. -55.57. What is the difference between the Gross enrolment ratio (%) in Central Europe in 2002 and the Gross enrolment ratio (%) in Costa Rica in 2005?
Provide a short and direct response. -4.46. What is the difference between the Gross enrolment ratio (%) in Central Europe in 2002 and the Gross enrolment ratio (%) in Maldives in 2005?
Offer a very short reply. -5.52. What is the difference between the Gross enrolment ratio (%) in Costa Rica in 2002 and the Gross enrolment ratio (%) in Maldives in 2005?
Offer a terse response. -9. What is the difference between the Gross enrolment ratio (%) of Arab World in 2004 and the Gross enrolment ratio (%) of Central Europe in 2005?
Your answer should be very brief. -54.91. What is the difference between the Gross enrolment ratio (%) in Arab World in 2004 and the Gross enrolment ratio (%) in Costa Rica in 2005?
Your response must be concise. -53.67. What is the difference between the Gross enrolment ratio (%) in Arab World in 2004 and the Gross enrolment ratio (%) in Maldives in 2005?
Ensure brevity in your answer.  -54.73. What is the difference between the Gross enrolment ratio (%) of Central Europe in 2004 and the Gross enrolment ratio (%) of Costa Rica in 2005?
Keep it short and to the point. -1.1. What is the difference between the Gross enrolment ratio (%) in Central Europe in 2004 and the Gross enrolment ratio (%) in Maldives in 2005?
Your answer should be compact. -2.16. What is the difference between the Gross enrolment ratio (%) in Costa Rica in 2004 and the Gross enrolment ratio (%) in Maldives in 2005?
Make the answer very short. -5.9. What is the average Gross enrolment ratio (%) in Arab World per year?
Make the answer very short. 15.12. What is the average Gross enrolment ratio (%) of Central Europe per year?
Provide a short and direct response. 64.54. What is the average Gross enrolment ratio (%) of Costa Rica per year?
Provide a succinct answer. 55.81. What is the average Gross enrolment ratio (%) of Maldives per year?
Provide a short and direct response. 61.47. In the year 1998, what is the difference between the Gross enrolment ratio (%) in Arab World and Gross enrolment ratio (%) in Central Europe?
Give a very brief answer. -44.2. In the year 1998, what is the difference between the Gross enrolment ratio (%) in Arab World and Gross enrolment ratio (%) in Costa Rica?
Your answer should be compact. -27.09. In the year 1998, what is the difference between the Gross enrolment ratio (%) of Arab World and Gross enrolment ratio (%) of Maldives?
Your answer should be compact. -37.61. In the year 1998, what is the difference between the Gross enrolment ratio (%) in Central Europe and Gross enrolment ratio (%) in Costa Rica?
Offer a terse response. 17.1. In the year 1998, what is the difference between the Gross enrolment ratio (%) in Central Europe and Gross enrolment ratio (%) in Maldives?
Your answer should be very brief. 6.59. In the year 1998, what is the difference between the Gross enrolment ratio (%) in Costa Rica and Gross enrolment ratio (%) in Maldives?
Offer a very short reply. -10.52. In the year 1999, what is the difference between the Gross enrolment ratio (%) of Arab World and Gross enrolment ratio (%) of Central Europe?
Offer a very short reply. -47.45. In the year 1999, what is the difference between the Gross enrolment ratio (%) in Arab World and Gross enrolment ratio (%) in Costa Rica?
Your answer should be very brief. -33. In the year 1999, what is the difference between the Gross enrolment ratio (%) of Arab World and Gross enrolment ratio (%) of Maldives?
Provide a succinct answer. -41.34. In the year 1999, what is the difference between the Gross enrolment ratio (%) in Central Europe and Gross enrolment ratio (%) in Costa Rica?
Provide a short and direct response. 14.45. In the year 1999, what is the difference between the Gross enrolment ratio (%) of Central Europe and Gross enrolment ratio (%) of Maldives?
Your answer should be compact. 6.11. In the year 1999, what is the difference between the Gross enrolment ratio (%) in Costa Rica and Gross enrolment ratio (%) in Maldives?
Offer a very short reply. -8.34. In the year 2000, what is the difference between the Gross enrolment ratio (%) in Arab World and Gross enrolment ratio (%) in Central Europe?
Make the answer very short. -48.26. In the year 2000, what is the difference between the Gross enrolment ratio (%) of Arab World and Gross enrolment ratio (%) of Costa Rica?
Provide a short and direct response. -32. In the year 2000, what is the difference between the Gross enrolment ratio (%) of Arab World and Gross enrolment ratio (%) of Maldives?
Give a very brief answer. -46.25. In the year 2000, what is the difference between the Gross enrolment ratio (%) of Central Europe and Gross enrolment ratio (%) of Costa Rica?
Provide a succinct answer. 16.26. In the year 2000, what is the difference between the Gross enrolment ratio (%) of Central Europe and Gross enrolment ratio (%) of Maldives?
Your answer should be compact. 2.01. In the year 2000, what is the difference between the Gross enrolment ratio (%) in Costa Rica and Gross enrolment ratio (%) in Maldives?
Your answer should be compact. -14.25. In the year 2001, what is the difference between the Gross enrolment ratio (%) in Arab World and Gross enrolment ratio (%) in Central Europe?
Your answer should be very brief. -49.17. In the year 2001, what is the difference between the Gross enrolment ratio (%) in Arab World and Gross enrolment ratio (%) in Costa Rica?
Your answer should be compact. -44.39. In the year 2001, what is the difference between the Gross enrolment ratio (%) of Arab World and Gross enrolment ratio (%) of Maldives?
Provide a succinct answer. -46.85. In the year 2001, what is the difference between the Gross enrolment ratio (%) of Central Europe and Gross enrolment ratio (%) of Costa Rica?
Your answer should be compact. 4.78. In the year 2001, what is the difference between the Gross enrolment ratio (%) in Central Europe and Gross enrolment ratio (%) in Maldives?
Give a very brief answer. 2.32. In the year 2001, what is the difference between the Gross enrolment ratio (%) of Costa Rica and Gross enrolment ratio (%) of Maldives?
Keep it short and to the point. -2.46. In the year 2002, what is the difference between the Gross enrolment ratio (%) of Arab World and Gross enrolment ratio (%) of Central Europe?
Make the answer very short. -50.05. In the year 2002, what is the difference between the Gross enrolment ratio (%) in Arab World and Gross enrolment ratio (%) in Costa Rica?
Give a very brief answer. -46.57. In the year 2002, what is the difference between the Gross enrolment ratio (%) of Arab World and Gross enrolment ratio (%) of Maldives?
Offer a terse response. -47.71. In the year 2002, what is the difference between the Gross enrolment ratio (%) of Central Europe and Gross enrolment ratio (%) of Costa Rica?
Your answer should be compact. 3.48. In the year 2002, what is the difference between the Gross enrolment ratio (%) in Central Europe and Gross enrolment ratio (%) in Maldives?
Your response must be concise. 2.35. In the year 2002, what is the difference between the Gross enrolment ratio (%) of Costa Rica and Gross enrolment ratio (%) of Maldives?
Offer a terse response. -1.14. In the year 2004, what is the difference between the Gross enrolment ratio (%) in Arab World and Gross enrolment ratio (%) in Central Europe?
Your answer should be compact. -52.57. In the year 2004, what is the difference between the Gross enrolment ratio (%) in Arab World and Gross enrolment ratio (%) in Costa Rica?
Provide a succinct answer. -48.83. In the year 2004, what is the difference between the Gross enrolment ratio (%) of Arab World and Gross enrolment ratio (%) of Maldives?
Offer a terse response. -50.68. In the year 2004, what is the difference between the Gross enrolment ratio (%) in Central Europe and Gross enrolment ratio (%) in Costa Rica?
Offer a terse response. 3.74. In the year 2004, what is the difference between the Gross enrolment ratio (%) in Central Europe and Gross enrolment ratio (%) in Maldives?
Your response must be concise. 1.89. In the year 2004, what is the difference between the Gross enrolment ratio (%) of Costa Rica and Gross enrolment ratio (%) of Maldives?
Provide a short and direct response. -1.85. In the year 2005, what is the difference between the Gross enrolment ratio (%) in Arab World and Gross enrolment ratio (%) in Central Europe?
Provide a succinct answer. -54.2. In the year 2005, what is the difference between the Gross enrolment ratio (%) in Arab World and Gross enrolment ratio (%) in Costa Rica?
Give a very brief answer. -52.95. In the year 2005, what is the difference between the Gross enrolment ratio (%) of Arab World and Gross enrolment ratio (%) of Maldives?
Keep it short and to the point. -54.01. In the year 2005, what is the difference between the Gross enrolment ratio (%) in Central Europe and Gross enrolment ratio (%) in Costa Rica?
Your response must be concise. 1.25. In the year 2005, what is the difference between the Gross enrolment ratio (%) of Central Europe and Gross enrolment ratio (%) of Maldives?
Your response must be concise. 0.19. In the year 2005, what is the difference between the Gross enrolment ratio (%) of Costa Rica and Gross enrolment ratio (%) of Maldives?
Your answer should be compact. -1.06. What is the ratio of the Gross enrolment ratio (%) in Arab World in 1998 to that in 1999?
Provide a short and direct response. 1.02. What is the ratio of the Gross enrolment ratio (%) of Central Europe in 1998 to that in 1999?
Give a very brief answer. 0.95. What is the ratio of the Gross enrolment ratio (%) in Costa Rica in 1998 to that in 1999?
Your answer should be very brief. 0.88. What is the ratio of the Gross enrolment ratio (%) in Maldives in 1998 to that in 1999?
Your response must be concise. 0.94. What is the ratio of the Gross enrolment ratio (%) of Arab World in 1998 to that in 2000?
Your response must be concise. 0.98. What is the ratio of the Gross enrolment ratio (%) in Central Europe in 1998 to that in 2000?
Ensure brevity in your answer.  0.93. What is the ratio of the Gross enrolment ratio (%) of Costa Rica in 1998 to that in 2000?
Your answer should be compact. 0.89. What is the ratio of the Gross enrolment ratio (%) of Maldives in 1998 to that in 2000?
Give a very brief answer. 0.85. What is the ratio of the Gross enrolment ratio (%) of Arab World in 1998 to that in 2001?
Keep it short and to the point. 0.99. What is the ratio of the Gross enrolment ratio (%) of Central Europe in 1998 to that in 2001?
Keep it short and to the point. 0.92. What is the ratio of the Gross enrolment ratio (%) in Costa Rica in 1998 to that in 2001?
Offer a very short reply. 0.7. What is the ratio of the Gross enrolment ratio (%) of Maldives in 1998 to that in 2001?
Give a very brief answer. 0.85. What is the ratio of the Gross enrolment ratio (%) of Arab World in 1998 to that in 2002?
Your answer should be compact. 0.97. What is the ratio of the Gross enrolment ratio (%) of Central Europe in 1998 to that in 2002?
Your answer should be very brief. 0.9. What is the ratio of the Gross enrolment ratio (%) of Costa Rica in 1998 to that in 2002?
Make the answer very short. 0.68. What is the ratio of the Gross enrolment ratio (%) in Maldives in 1998 to that in 2002?
Your response must be concise. 0.83. What is the ratio of the Gross enrolment ratio (%) in Arab World in 1998 to that in 2004?
Make the answer very short. 0.92. What is the ratio of the Gross enrolment ratio (%) in Central Europe in 1998 to that in 2004?
Keep it short and to the point. 0.86. What is the ratio of the Gross enrolment ratio (%) of Costa Rica in 1998 to that in 2004?
Your response must be concise. 0.64. What is the ratio of the Gross enrolment ratio (%) in Maldives in 1998 to that in 2004?
Offer a very short reply. 0.78. What is the ratio of the Gross enrolment ratio (%) of Arab World in 1998 to that in 2005?
Offer a terse response. 0.88. What is the ratio of the Gross enrolment ratio (%) of Central Europe in 1998 to that in 2005?
Keep it short and to the point. 0.83. What is the ratio of the Gross enrolment ratio (%) of Costa Rica in 1998 to that in 2005?
Offer a very short reply. 0.6. What is the ratio of the Gross enrolment ratio (%) of Maldives in 1998 to that in 2005?
Provide a succinct answer. 0.74. What is the ratio of the Gross enrolment ratio (%) of Arab World in 1999 to that in 2000?
Give a very brief answer. 0.97. What is the ratio of the Gross enrolment ratio (%) of Central Europe in 1999 to that in 2000?
Your answer should be very brief. 0.98. What is the ratio of the Gross enrolment ratio (%) of Costa Rica in 1999 to that in 2000?
Ensure brevity in your answer.  1.01. What is the ratio of the Gross enrolment ratio (%) in Maldives in 1999 to that in 2000?
Your answer should be compact. 0.91. What is the ratio of the Gross enrolment ratio (%) of Arab World in 1999 to that in 2001?
Offer a terse response. 0.97. What is the ratio of the Gross enrolment ratio (%) of Central Europe in 1999 to that in 2001?
Offer a terse response. 0.97. What is the ratio of the Gross enrolment ratio (%) in Costa Rica in 1999 to that in 2001?
Make the answer very short. 0.8. What is the ratio of the Gross enrolment ratio (%) of Maldives in 1999 to that in 2001?
Offer a terse response. 0.9. What is the ratio of the Gross enrolment ratio (%) in Arab World in 1999 to that in 2002?
Make the answer very short. 0.96. What is the ratio of the Gross enrolment ratio (%) in Central Europe in 1999 to that in 2002?
Make the answer very short. 0.95. What is the ratio of the Gross enrolment ratio (%) of Costa Rica in 1999 to that in 2002?
Offer a very short reply. 0.77. What is the ratio of the Gross enrolment ratio (%) in Maldives in 1999 to that in 2002?
Your answer should be compact. 0.89. What is the ratio of the Gross enrolment ratio (%) of Arab World in 1999 to that in 2004?
Ensure brevity in your answer.  0.91. What is the ratio of the Gross enrolment ratio (%) in Central Europe in 1999 to that in 2004?
Ensure brevity in your answer.  0.9. What is the ratio of the Gross enrolment ratio (%) of Costa Rica in 1999 to that in 2004?
Keep it short and to the point. 0.73. What is the ratio of the Gross enrolment ratio (%) in Maldives in 1999 to that in 2004?
Ensure brevity in your answer.  0.84. What is the ratio of the Gross enrolment ratio (%) in Arab World in 1999 to that in 2005?
Provide a short and direct response. 0.87. What is the ratio of the Gross enrolment ratio (%) of Central Europe in 1999 to that in 2005?
Offer a very short reply. 0.87. What is the ratio of the Gross enrolment ratio (%) of Costa Rica in 1999 to that in 2005?
Keep it short and to the point. 0.68. What is the ratio of the Gross enrolment ratio (%) in Maldives in 1999 to that in 2005?
Provide a short and direct response. 0.79. What is the ratio of the Gross enrolment ratio (%) of Arab World in 2000 to that in 2001?
Provide a succinct answer. 1. What is the ratio of the Gross enrolment ratio (%) in Central Europe in 2000 to that in 2001?
Your response must be concise. 0.99. What is the ratio of the Gross enrolment ratio (%) of Costa Rica in 2000 to that in 2001?
Ensure brevity in your answer.  0.79. What is the ratio of the Gross enrolment ratio (%) in Arab World in 2000 to that in 2002?
Your answer should be very brief. 0.99. What is the ratio of the Gross enrolment ratio (%) of Central Europe in 2000 to that in 2002?
Provide a succinct answer. 0.97. What is the ratio of the Gross enrolment ratio (%) of Costa Rica in 2000 to that in 2002?
Ensure brevity in your answer.  0.76. What is the ratio of the Gross enrolment ratio (%) of Maldives in 2000 to that in 2002?
Offer a terse response. 0.97. What is the ratio of the Gross enrolment ratio (%) of Arab World in 2000 to that in 2004?
Your answer should be compact. 0.93. What is the ratio of the Gross enrolment ratio (%) of Central Europe in 2000 to that in 2004?
Your answer should be very brief. 0.92. What is the ratio of the Gross enrolment ratio (%) of Costa Rica in 2000 to that in 2004?
Ensure brevity in your answer.  0.72. What is the ratio of the Gross enrolment ratio (%) in Maldives in 2000 to that in 2004?
Keep it short and to the point. 0.92. What is the ratio of the Gross enrolment ratio (%) of Arab World in 2000 to that in 2005?
Ensure brevity in your answer.  0.89. What is the ratio of the Gross enrolment ratio (%) in Central Europe in 2000 to that in 2005?
Offer a terse response. 0.89. What is the ratio of the Gross enrolment ratio (%) of Costa Rica in 2000 to that in 2005?
Offer a very short reply. 0.67. What is the ratio of the Gross enrolment ratio (%) of Maldives in 2000 to that in 2005?
Keep it short and to the point. 0.87. What is the ratio of the Gross enrolment ratio (%) of Central Europe in 2001 to that in 2002?
Your answer should be compact. 0.98. What is the ratio of the Gross enrolment ratio (%) of Costa Rica in 2001 to that in 2002?
Your answer should be compact. 0.96. What is the ratio of the Gross enrolment ratio (%) of Maldives in 2001 to that in 2002?
Your response must be concise. 0.98. What is the ratio of the Gross enrolment ratio (%) of Arab World in 2001 to that in 2004?
Keep it short and to the point. 0.93. What is the ratio of the Gross enrolment ratio (%) of Central Europe in 2001 to that in 2004?
Offer a very short reply. 0.93. What is the ratio of the Gross enrolment ratio (%) in Costa Rica in 2001 to that in 2004?
Your answer should be very brief. 0.91. What is the ratio of the Gross enrolment ratio (%) in Maldives in 2001 to that in 2004?
Your answer should be very brief. 0.93. What is the ratio of the Gross enrolment ratio (%) of Arab World in 2001 to that in 2005?
Your answer should be very brief. 0.89. What is the ratio of the Gross enrolment ratio (%) in Central Europe in 2001 to that in 2005?
Your answer should be compact. 0.9. What is the ratio of the Gross enrolment ratio (%) in Costa Rica in 2001 to that in 2005?
Provide a succinct answer. 0.85. What is the ratio of the Gross enrolment ratio (%) of Maldives in 2001 to that in 2005?
Your answer should be compact. 0.87. What is the ratio of the Gross enrolment ratio (%) in Arab World in 2002 to that in 2004?
Offer a terse response. 0.95. What is the ratio of the Gross enrolment ratio (%) in Central Europe in 2002 to that in 2004?
Offer a terse response. 0.95. What is the ratio of the Gross enrolment ratio (%) of Maldives in 2002 to that in 2004?
Make the answer very short. 0.94. What is the ratio of the Gross enrolment ratio (%) of Arab World in 2002 to that in 2005?
Offer a very short reply. 0.91. What is the ratio of the Gross enrolment ratio (%) of Central Europe in 2002 to that in 2005?
Your answer should be compact. 0.92. What is the ratio of the Gross enrolment ratio (%) in Costa Rica in 2002 to that in 2005?
Your answer should be very brief. 0.89. What is the ratio of the Gross enrolment ratio (%) in Maldives in 2002 to that in 2005?
Make the answer very short. 0.89. What is the ratio of the Gross enrolment ratio (%) of Arab World in 2004 to that in 2005?
Make the answer very short. 0.96. What is the ratio of the Gross enrolment ratio (%) of Central Europe in 2004 to that in 2005?
Your answer should be compact. 0.97. What is the ratio of the Gross enrolment ratio (%) in Costa Rica in 2004 to that in 2005?
Offer a very short reply. 0.93. What is the ratio of the Gross enrolment ratio (%) in Maldives in 2004 to that in 2005?
Your answer should be compact. 0.94. What is the difference between the highest and the second highest Gross enrolment ratio (%) of Arab World?
Provide a short and direct response. 0.72. What is the difference between the highest and the second highest Gross enrolment ratio (%) of Central Europe?
Your answer should be compact. 2.35. What is the difference between the highest and the second highest Gross enrolment ratio (%) of Costa Rica?
Offer a very short reply. 4.84. What is the difference between the highest and the second highest Gross enrolment ratio (%) in Maldives?
Provide a succinct answer. 4.05. What is the difference between the highest and the lowest Gross enrolment ratio (%) in Arab World?
Keep it short and to the point. 2.21. What is the difference between the highest and the lowest Gross enrolment ratio (%) of Central Europe?
Your answer should be compact. 11.99. What is the difference between the highest and the lowest Gross enrolment ratio (%) in Costa Rica?
Provide a succinct answer. 27.85. What is the difference between the highest and the lowest Gross enrolment ratio (%) in Maldives?
Provide a succinct answer. 18.39. 